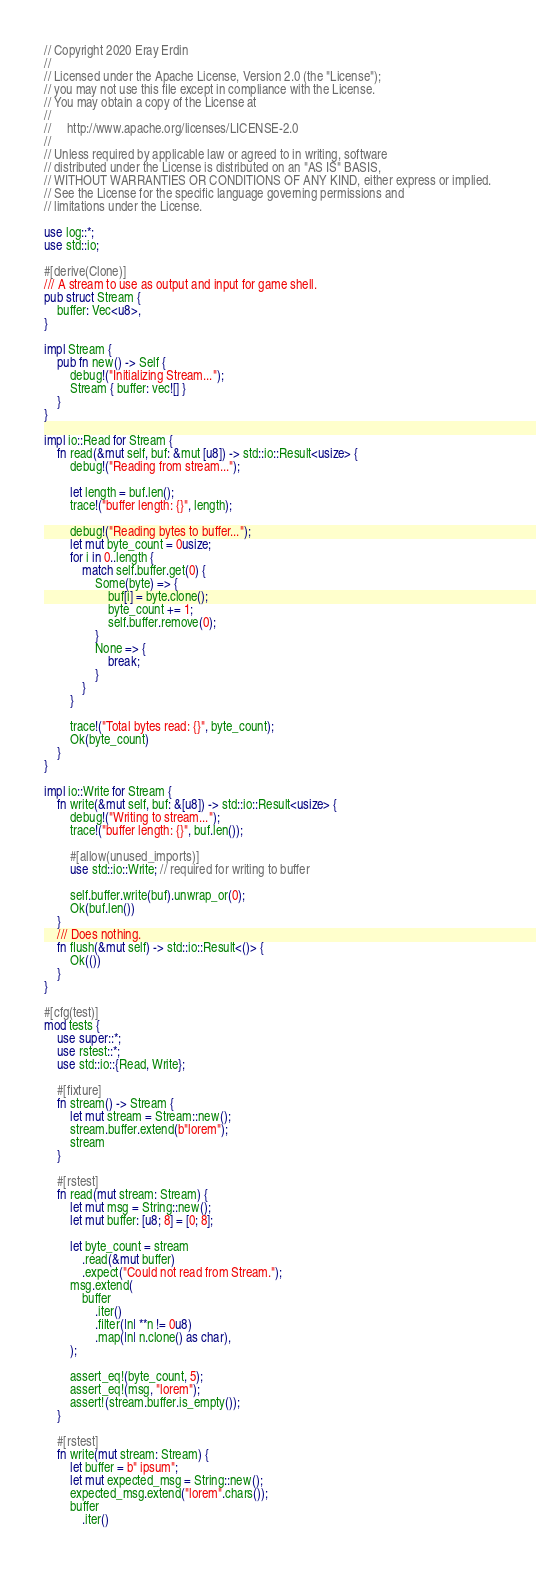<code> <loc_0><loc_0><loc_500><loc_500><_Rust_>// Copyright 2020 Eray Erdin
//
// Licensed under the Apache License, Version 2.0 (the "License");
// you may not use this file except in compliance with the License.
// You may obtain a copy of the License at
//
//     http://www.apache.org/licenses/LICENSE-2.0
//
// Unless required by applicable law or agreed to in writing, software
// distributed under the License is distributed on an "AS IS" BASIS,
// WITHOUT WARRANTIES OR CONDITIONS OF ANY KIND, either express or implied.
// See the License for the specific language governing permissions and
// limitations under the License.

use log::*;
use std::io;

#[derive(Clone)]
/// A stream to use as output and input for game shell.
pub struct Stream {
    buffer: Vec<u8>,
}

impl Stream {
    pub fn new() -> Self {
        debug!("Initializing Stream...");
        Stream { buffer: vec![] }
    }
}

impl io::Read for Stream {
    fn read(&mut self, buf: &mut [u8]) -> std::io::Result<usize> {
        debug!("Reading from stream...");

        let length = buf.len();
        trace!("buffer length: {}", length);

        debug!("Reading bytes to buffer...");
        let mut byte_count = 0usize;
        for i in 0..length {
            match self.buffer.get(0) {
                Some(byte) => {
                    buf[i] = byte.clone();
                    byte_count += 1;
                    self.buffer.remove(0);
                }
                None => {
                    break;
                }
            }
        }

        trace!("Total bytes read: {}", byte_count);
        Ok(byte_count)
    }
}

impl io::Write for Stream {
    fn write(&mut self, buf: &[u8]) -> std::io::Result<usize> {
        debug!("Writing to stream...");
        trace!("buffer length: {}", buf.len());

        #[allow(unused_imports)]
        use std::io::Write; // required for writing to buffer

        self.buffer.write(buf).unwrap_or(0);
        Ok(buf.len())
    }
    /// Does nothing.
    fn flush(&mut self) -> std::io::Result<()> {
        Ok(())
    }
}

#[cfg(test)]
mod tests {
    use super::*;
    use rstest::*;
    use std::io::{Read, Write};

    #[fixture]
    fn stream() -> Stream {
        let mut stream = Stream::new();
        stream.buffer.extend(b"lorem");
        stream
    }

    #[rstest]
    fn read(mut stream: Stream) {
        let mut msg = String::new();
        let mut buffer: [u8; 8] = [0; 8];

        let byte_count = stream
            .read(&mut buffer)
            .expect("Could not read from Stream.");
        msg.extend(
            buffer
                .iter()
                .filter(|n| **n != 0u8)
                .map(|n| n.clone() as char),
        );

        assert_eq!(byte_count, 5);
        assert_eq!(msg, "lorem");
        assert!(stream.buffer.is_empty());
    }

    #[rstest]
    fn write(mut stream: Stream) {
        let buffer = b" ipsum";
        let mut expected_msg = String::new();
        expected_msg.extend("lorem".chars());
        buffer
            .iter()</code> 